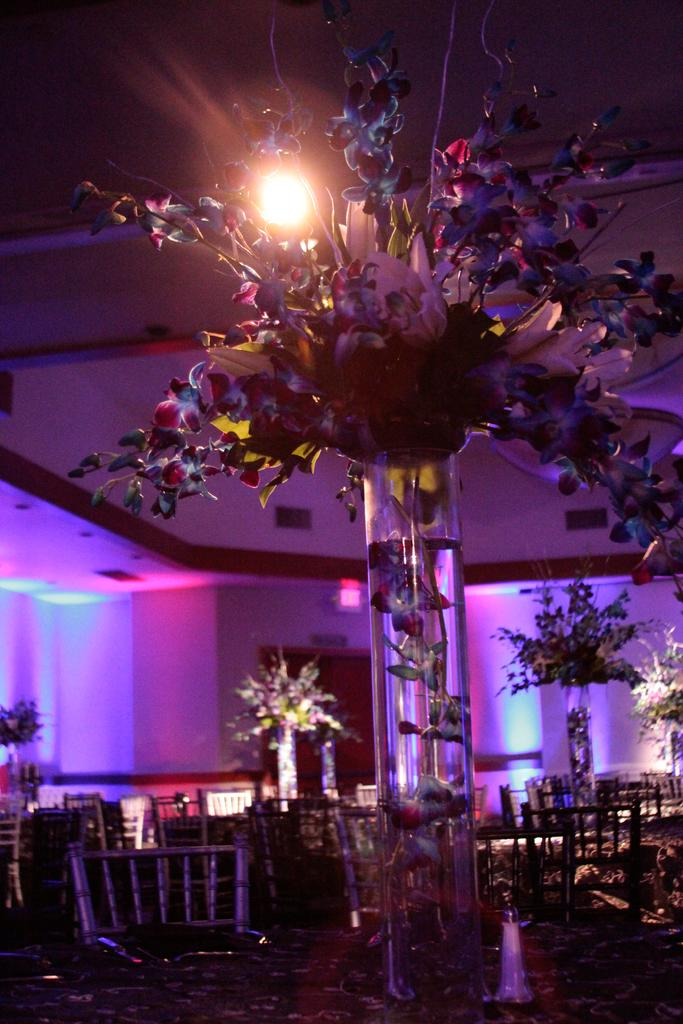What type of structure can be seen in the image? There is a wall in the image. What is the source of light in the image? There is a light in the image. What type of containers are present in the image? There are flower flasks in the image. What type of living organisms are in the image? There are plants in the image. What type of furniture is in the image? There is a table and a chair in the image. How would you describe the lighting in the image? The image is described as being a little dark. Can you see the river flowing in the image? There is no river present in the image. How comfortable is the chair in the image? The image does not provide information about the comfort of the chair. 